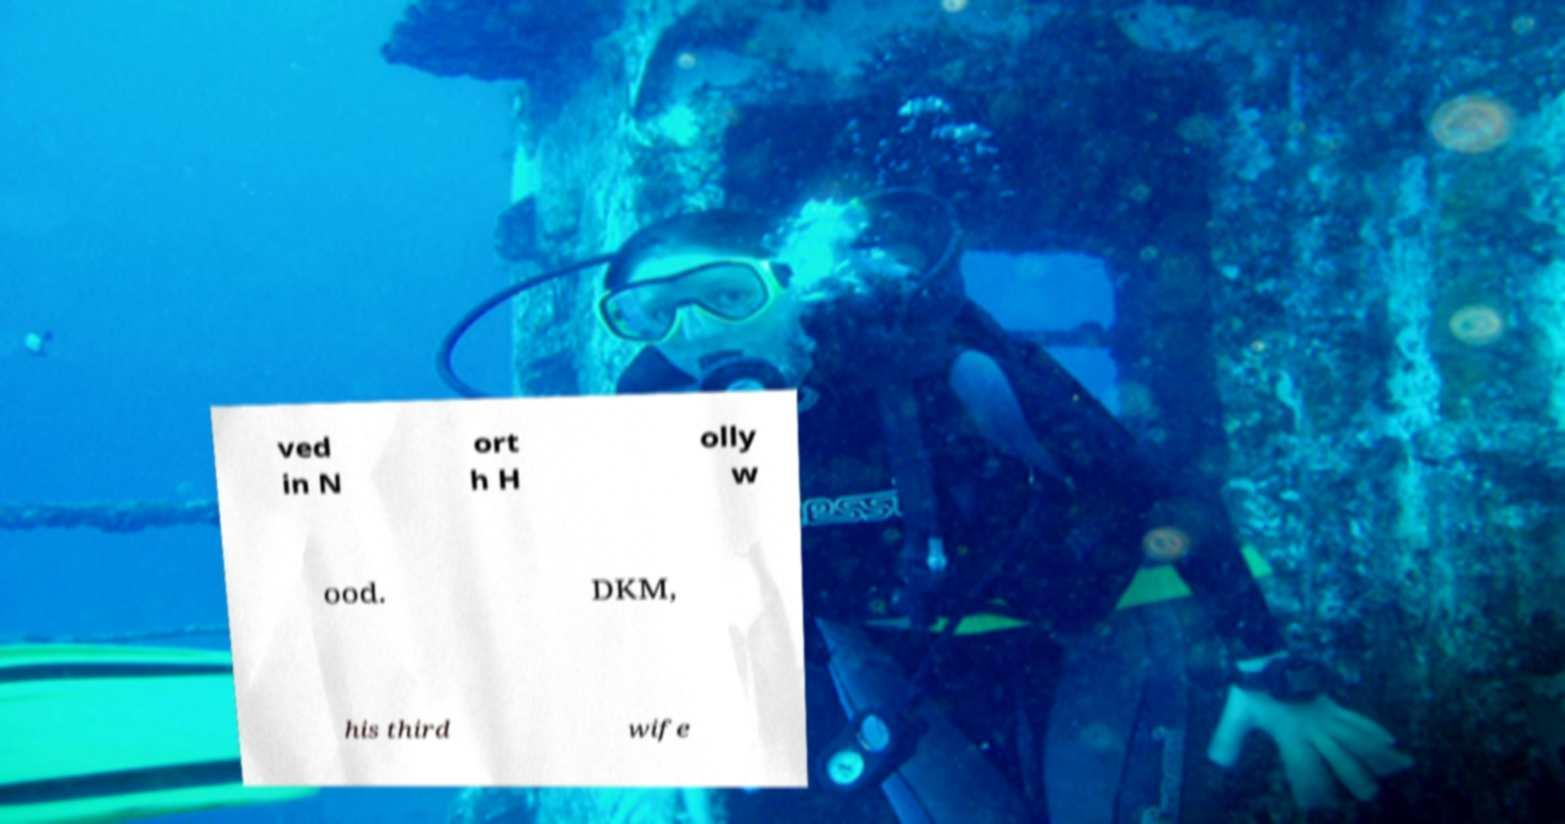Can you accurately transcribe the text from the provided image for me? ved in N ort h H olly w ood. DKM, his third wife 